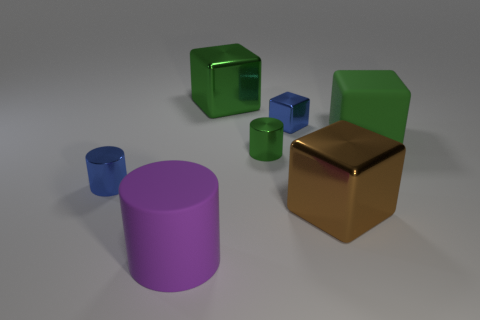What materials do the objects in the image look like they're made of? The objects in the image appear to have different materials. The large purple cylinder and the small blue cube look like they could be made of rubber due to their matte surfaces, while the golden cube has a reflective surface that suggests it could be made of metal. 